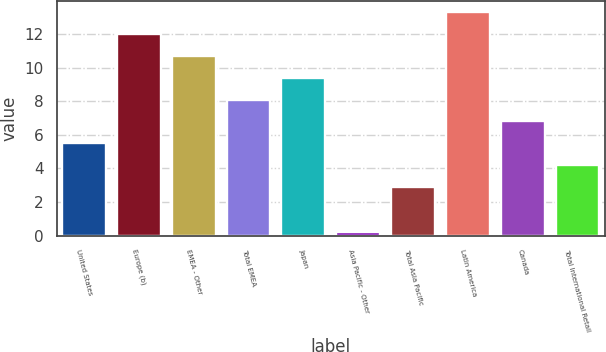Convert chart to OTSL. <chart><loc_0><loc_0><loc_500><loc_500><bar_chart><fcel>United States<fcel>Europe (b)<fcel>EMEA - Other<fcel>Total EMEA<fcel>Japan<fcel>Asia Pacific - Other<fcel>Total Asia Pacific<fcel>Latin America<fcel>Canada<fcel>Total International Retail<nl><fcel>5.5<fcel>12<fcel>10.7<fcel>8.1<fcel>9.4<fcel>0.2<fcel>2.9<fcel>13.3<fcel>6.8<fcel>4.2<nl></chart> 